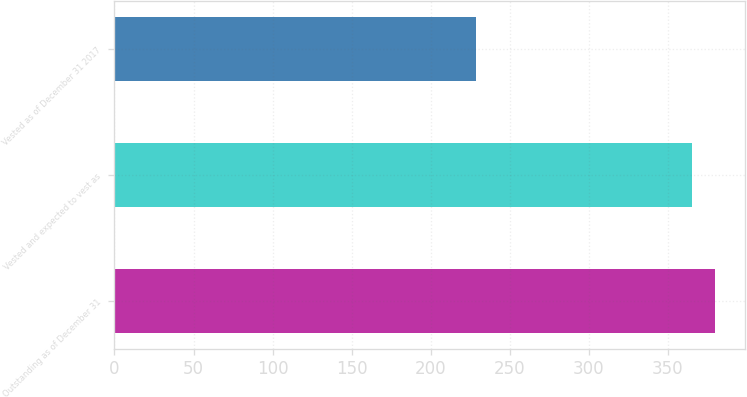Convert chart to OTSL. <chart><loc_0><loc_0><loc_500><loc_500><bar_chart><fcel>Outstanding as of December 31<fcel>Vested and expected to vest as<fcel>Vested as of December 31 2017<nl><fcel>379.73<fcel>365.3<fcel>228.5<nl></chart> 